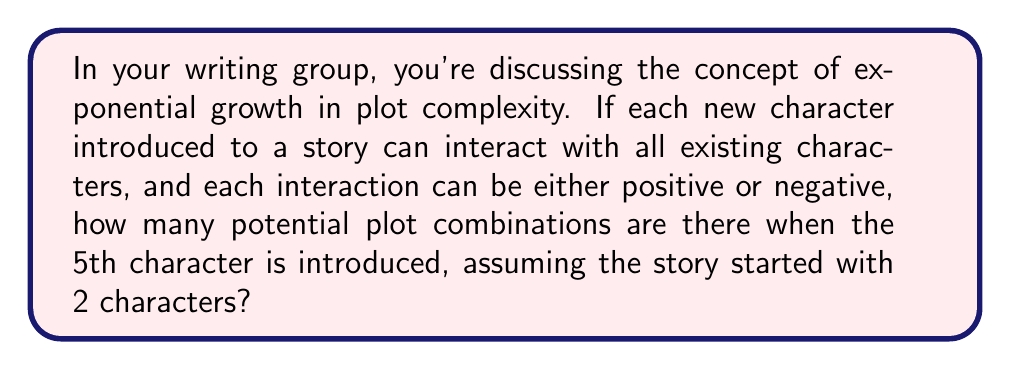Show me your answer to this math problem. Let's approach this step-by-step:

1) We start with 2 characters. Each new character can interact with all existing characters.

2) The number of interactions for each new character is equal to the number of existing characters.

3) Each interaction can be either positive or negative, giving us 2 possibilities for each interaction.

4) The number of plot combinations doubles with each new interaction.

5) Let's calculate the number of new interactions with each character addition:
   - 3rd character: 2 new interactions
   - 4th character: 3 new interactions
   - 5th character: 4 new interactions

6) Total new interactions: $2 + 3 + 4 = 9$

7) Each interaction doubles the possibilities, so we can represent this as:

   $$2^9 = 512$$

8) Therefore, when the 5th character is introduced, there are 512 potential plot combinations.

This exponential growth demonstrates why adding characters can quickly increase the complexity of a narrative.
Answer: $2^9 = 512$ combinations 